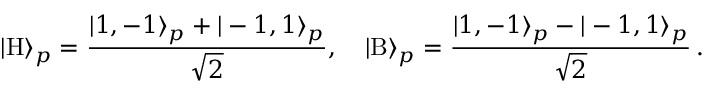Convert formula to latex. <formula><loc_0><loc_0><loc_500><loc_500>| \mathrm H \rangle _ { p } = \frac { | 1 , - 1 \rangle _ { p } + | - 1 , 1 \rangle _ { p } } { \sqrt { 2 } } , \quad | \mathrm B \rangle _ { p } = \frac { | 1 , - 1 \rangle _ { p } - | - 1 , 1 \rangle _ { p } } { \sqrt { 2 } } \, .</formula> 